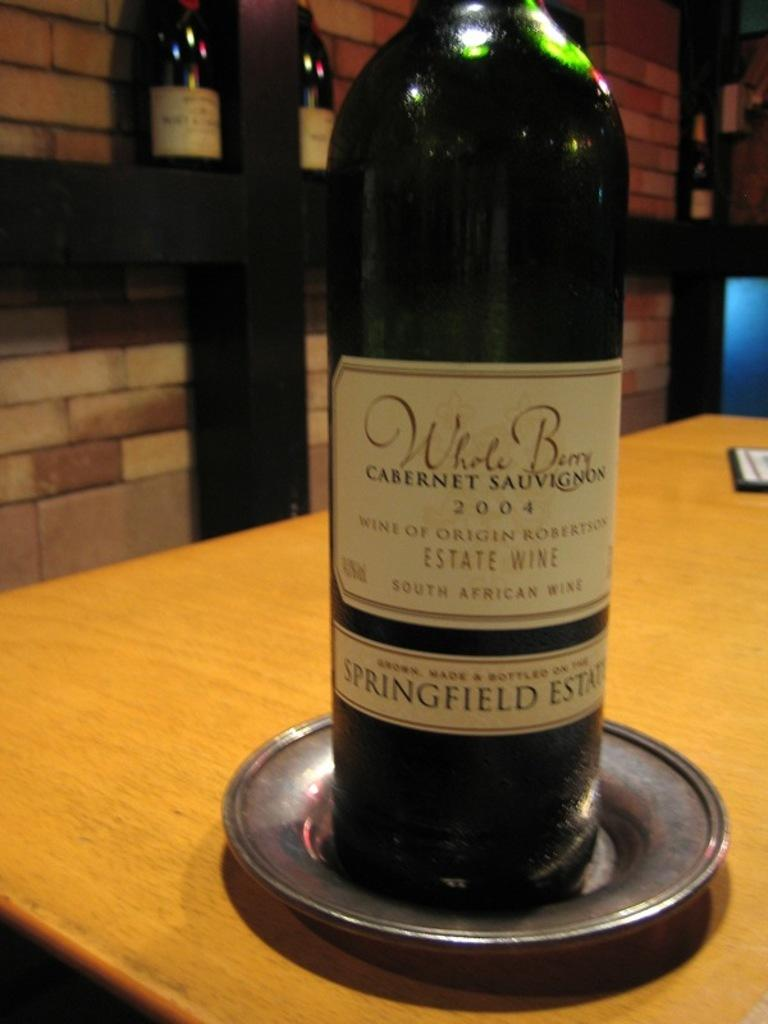<image>
Create a compact narrative representing the image presented. A bottle of South African wine called Whole Berry 